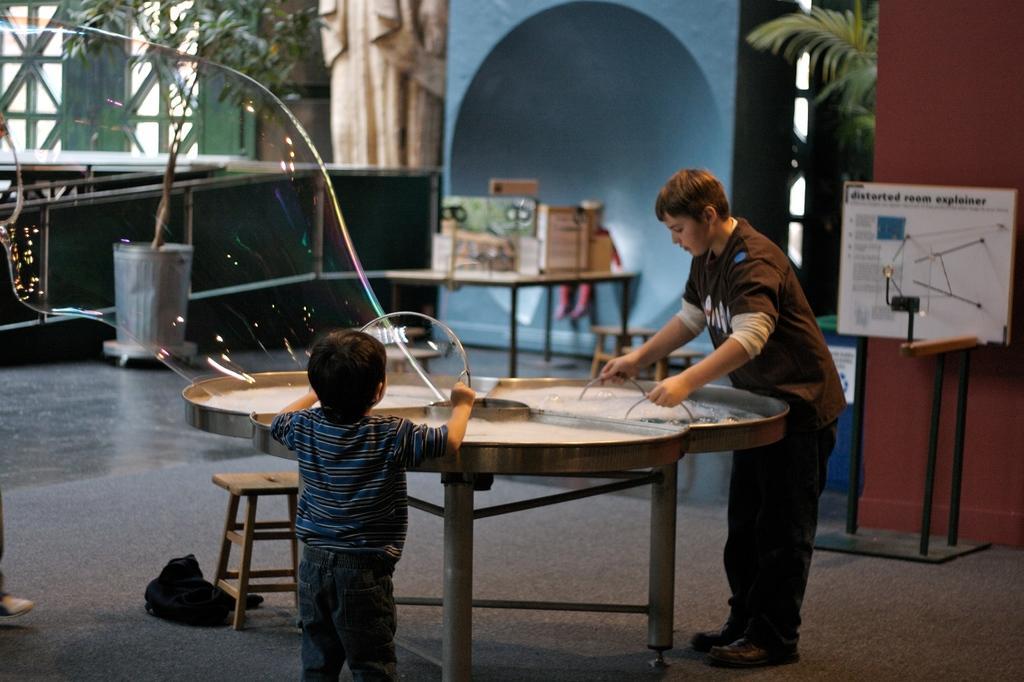Can you describe this image briefly? In this image there are two persons. At the right side boy is standing and doing some work on the table. In the center kid is standing and watching. In the background there are walls, plants, white colour board and stand. 